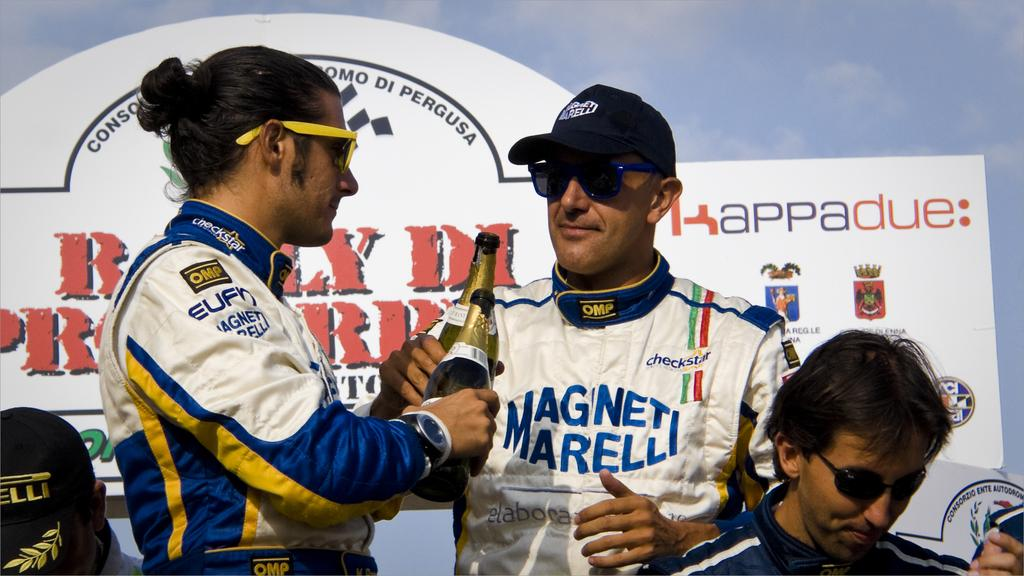<image>
Summarize the visual content of the image. an outfit that has the word magneti on it 